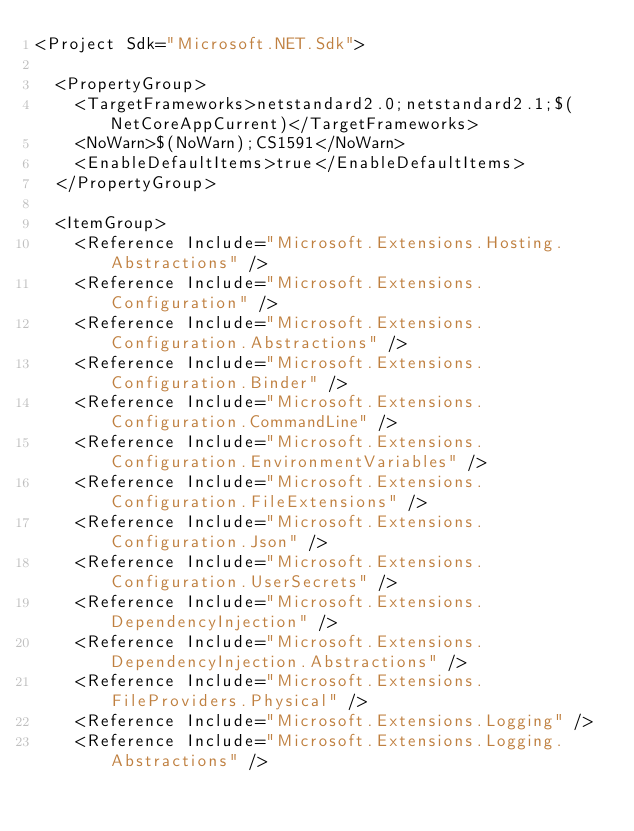Convert code to text. <code><loc_0><loc_0><loc_500><loc_500><_XML_><Project Sdk="Microsoft.NET.Sdk">

  <PropertyGroup>
    <TargetFrameworks>netstandard2.0;netstandard2.1;$(NetCoreAppCurrent)</TargetFrameworks>
    <NoWarn>$(NoWarn);CS1591</NoWarn>
    <EnableDefaultItems>true</EnableDefaultItems>
  </PropertyGroup>

  <ItemGroup>
    <Reference Include="Microsoft.Extensions.Hosting.Abstractions" />
    <Reference Include="Microsoft.Extensions.Configuration" />
    <Reference Include="Microsoft.Extensions.Configuration.Abstractions" />
    <Reference Include="Microsoft.Extensions.Configuration.Binder" />
    <Reference Include="Microsoft.Extensions.Configuration.CommandLine" />
    <Reference Include="Microsoft.Extensions.Configuration.EnvironmentVariables" />
    <Reference Include="Microsoft.Extensions.Configuration.FileExtensions" />
    <Reference Include="Microsoft.Extensions.Configuration.Json" />
    <Reference Include="Microsoft.Extensions.Configuration.UserSecrets" />
    <Reference Include="Microsoft.Extensions.DependencyInjection" />
    <Reference Include="Microsoft.Extensions.DependencyInjection.Abstractions" />
    <Reference Include="Microsoft.Extensions.FileProviders.Physical" />
    <Reference Include="Microsoft.Extensions.Logging" />
    <Reference Include="Microsoft.Extensions.Logging.Abstractions" /></code> 